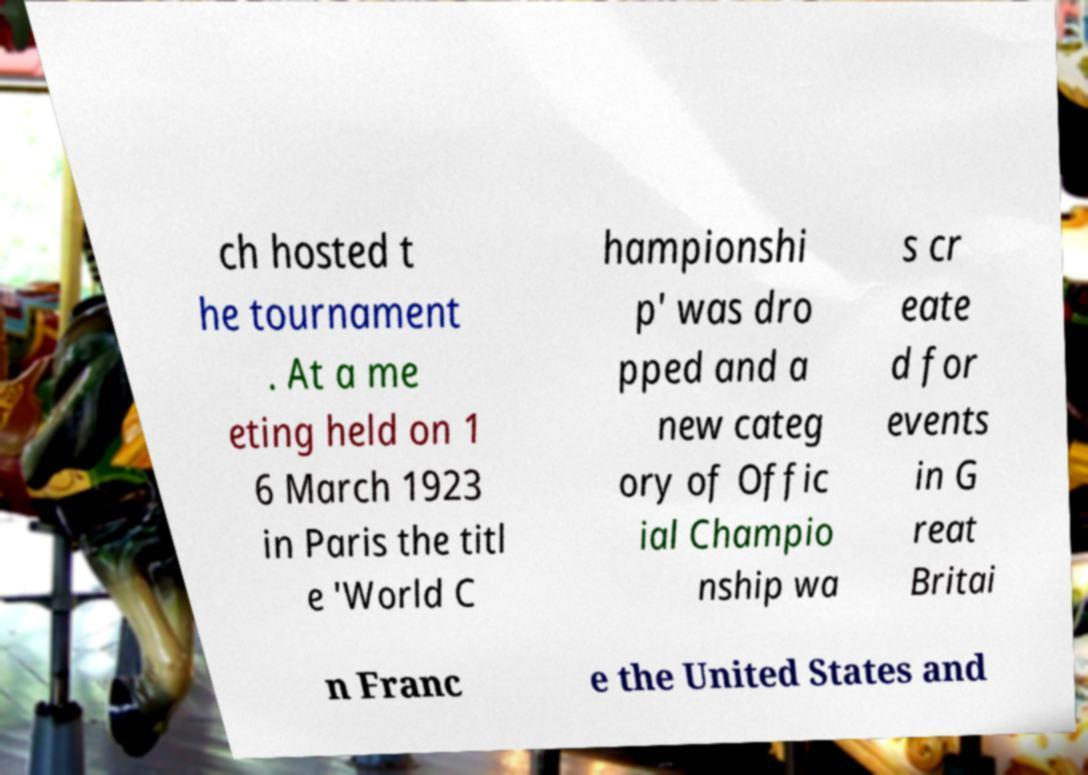What messages or text are displayed in this image? I need them in a readable, typed format. ch hosted t he tournament . At a me eting held on 1 6 March 1923 in Paris the titl e 'World C hampionshi p' was dro pped and a new categ ory of Offic ial Champio nship wa s cr eate d for events in G reat Britai n Franc e the United States and 